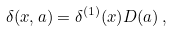Convert formula to latex. <formula><loc_0><loc_0><loc_500><loc_500>\delta ( { x } , a ) = \delta ^ { ( 1 ) } ( { x ) } D ( a ) \, ,</formula> 